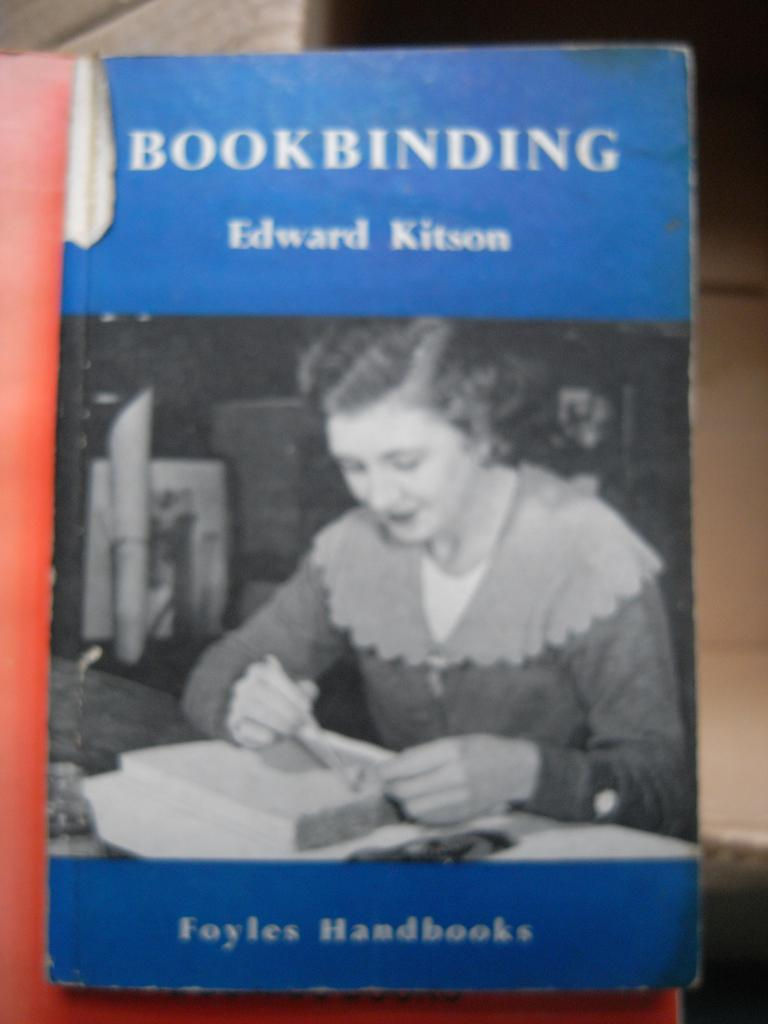<image>
Offer a succinct explanation of the picture presented. A book about book binding by Edward Kitson. 